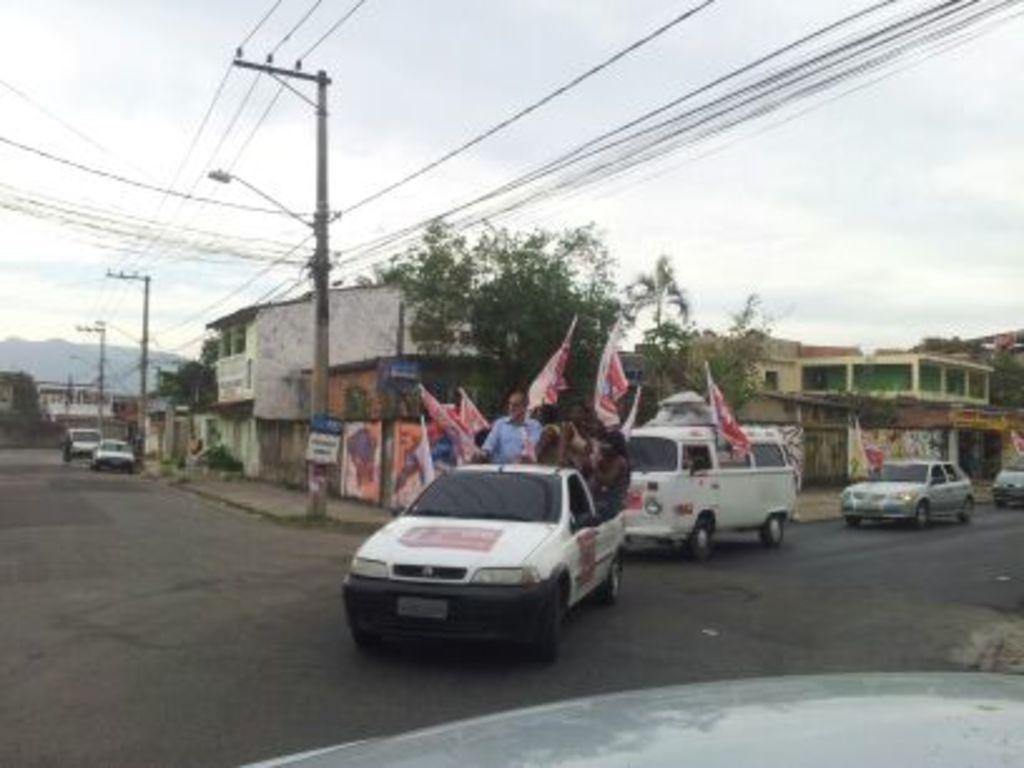What is the main subject of the image? The main subject of the image is a car. Who or what is inside the car? There are people in the car. What are the people in the car doing? The people in the car are holding flags. What else can be seen in the image besides the car and the people? There are other people around the car, houses, and poles with wires in the image. What word is written in the river in the image? There is no river present in the image, so it is not possible to answer that question. 